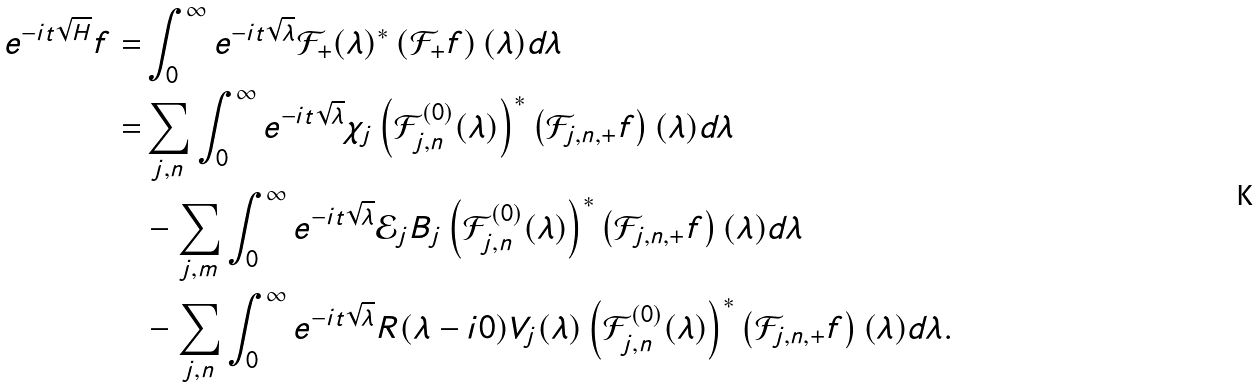<formula> <loc_0><loc_0><loc_500><loc_500>e ^ { - i t \sqrt { H } } f = & \int _ { 0 } ^ { \infty } e ^ { - i t \sqrt { \lambda } } \mathcal { F } _ { + } ( \lambda ) ^ { \ast } \left ( \mathcal { F } _ { + } f \right ) ( \lambda ) d \lambda \\ = & \sum _ { j , n } \int _ { 0 } ^ { \infty } e ^ { - i t \sqrt { \lambda } } \chi _ { j } \left ( \mathcal { F } _ { j , n } ^ { ( 0 ) } ( \lambda ) \right ) ^ { \ast } \left ( \mathcal { F } _ { j , n , + } f \right ) ( \lambda ) d \lambda \\ & - \sum _ { j , m } \int _ { 0 } ^ { \infty } e ^ { - i t \sqrt { \lambda } } \mathcal { E } _ { j } B _ { j } \left ( \mathcal { F } _ { j , n } ^ { ( 0 ) } ( \lambda ) \right ) ^ { \ast } \left ( \mathcal { F } _ { j , n , + } f \right ) ( \lambda ) d \lambda \\ & - \sum _ { j , n } \int _ { 0 } ^ { \infty } e ^ { - i t \sqrt { \lambda } } R ( \lambda - i 0 ) V _ { j } ( \lambda ) \left ( \mathcal { F } _ { j , n } ^ { ( 0 ) } ( \lambda ) \right ) ^ { \ast } \left ( \mathcal { F } _ { j , n , + } f \right ) ( \lambda ) d \lambda .</formula> 